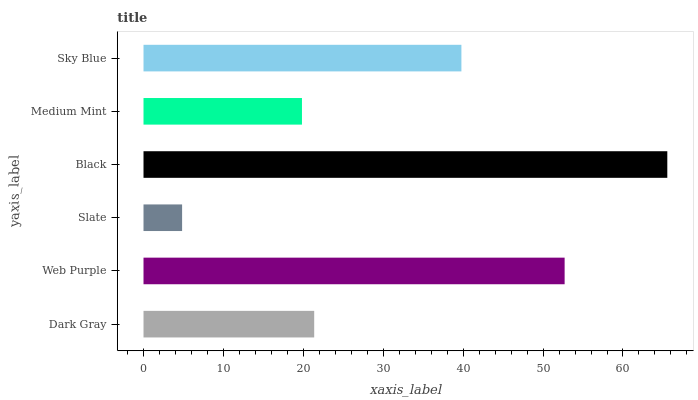Is Slate the minimum?
Answer yes or no. Yes. Is Black the maximum?
Answer yes or no. Yes. Is Web Purple the minimum?
Answer yes or no. No. Is Web Purple the maximum?
Answer yes or no. No. Is Web Purple greater than Dark Gray?
Answer yes or no. Yes. Is Dark Gray less than Web Purple?
Answer yes or no. Yes. Is Dark Gray greater than Web Purple?
Answer yes or no. No. Is Web Purple less than Dark Gray?
Answer yes or no. No. Is Sky Blue the high median?
Answer yes or no. Yes. Is Dark Gray the low median?
Answer yes or no. Yes. Is Medium Mint the high median?
Answer yes or no. No. Is Sky Blue the low median?
Answer yes or no. No. 